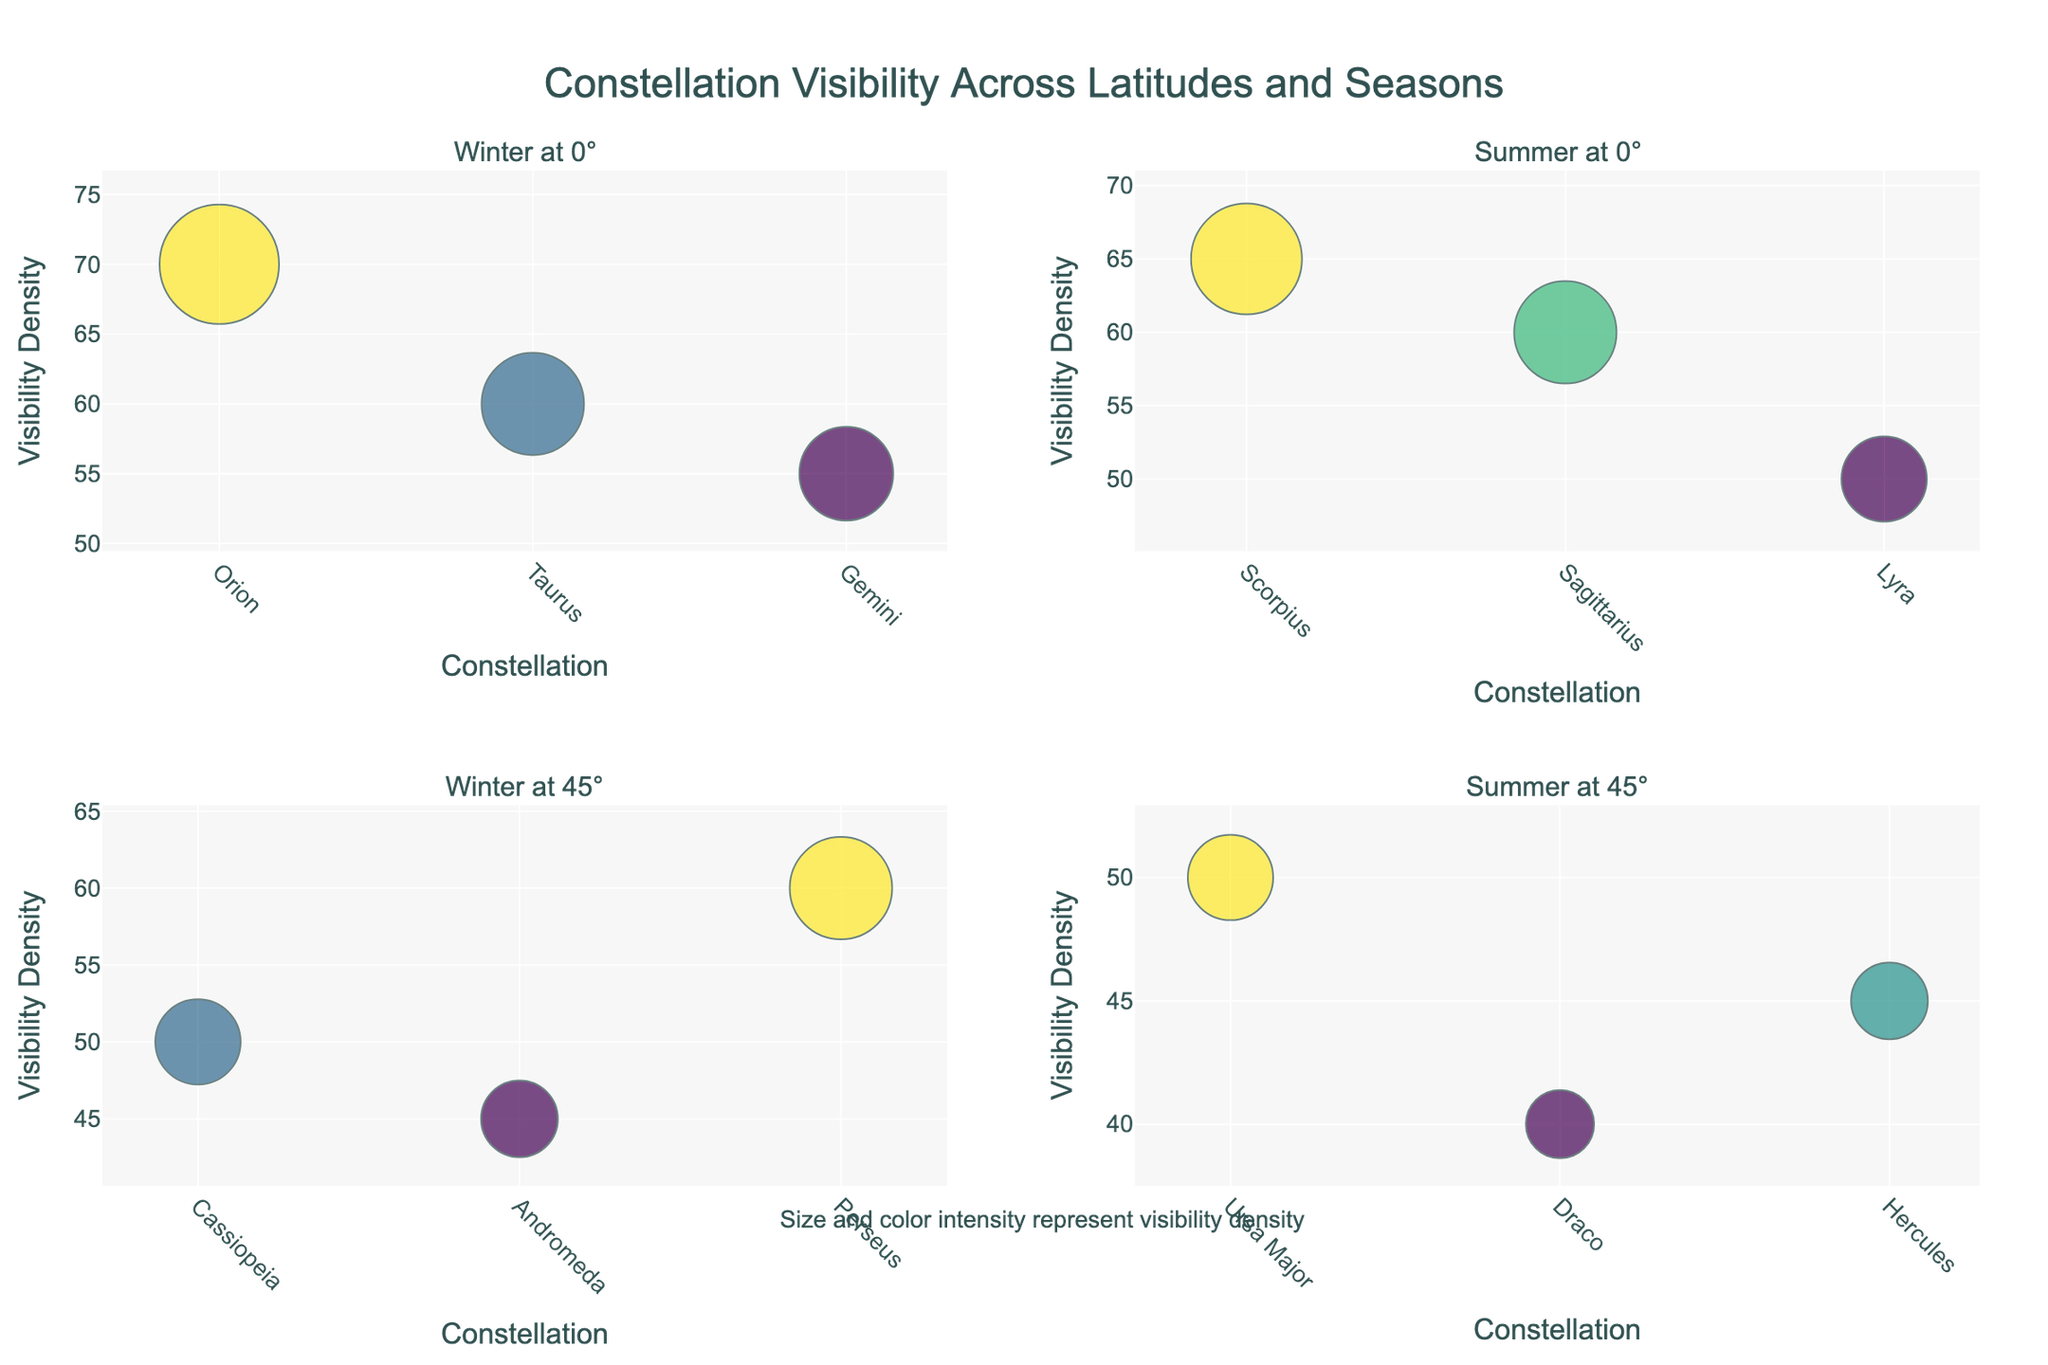What is the title of the figure? The title of the figure can be found at the top and provides an overview of the purpose of the visualization.
Answer: Constellation Visibility Across Latitudes and Seasons How many constellations are visible in the winter at 0° latitude according to the plot? To determine this, look at the subplot titled "Winter at 0°" and count the number of data points (markers) present.
Answer: 3 Which constellation has the highest visibility density in the winter at 45° latitude? Refer to the subplot titled "Winter at 45°" and identify the data point with the highest vertical position (y-value for density).
Answer: Perseus How does the visibility density of Scorpius in the summer at 0° latitude compare to Vega in the summer at 23.5° latitude? First, locate the subplot titled "Summer at 0°" and find the density for Scorpius. Then, look for the Vega density in the subplot for 23.5° latitude in the summer. Compare the values.
Answer: Scorpius has higher density What is the difference in visibility density between Orion and Taurus in the winter at 23.5° latitude? Look at the subplot titled "Winter at 23.5°" and find the densities for Orion and Taurus. Subtract the density of Taurus from that of Orion.
Answer: 10 Which constellation has the lowest visibility density in the summer at 60° latitude? Refer to the subplot titled "Summer at 60°" and identify the data point with the lowest vertical position (y-value for density).
Answer: Cepheus What is the average visibility density of constellations in the winter at 45° latitude? In the subplot "Winter at 45°," get the density values for Cassiopeia, Andromeda, and Perseus. Sum these values and divide by the number of constellations (3).
Answer: 51.67 How many constellations are represented in the figure for both 0° and 45° latitude combined? Count the data points (markers) in the subplots for both winter and summer at 0° and winter and summer at 45°.
Answer: 12 Is Lyra visible in the winter at any latitude in the figure? Check all the winter subplots for any data points labeled "Lyra."
Answer: No 